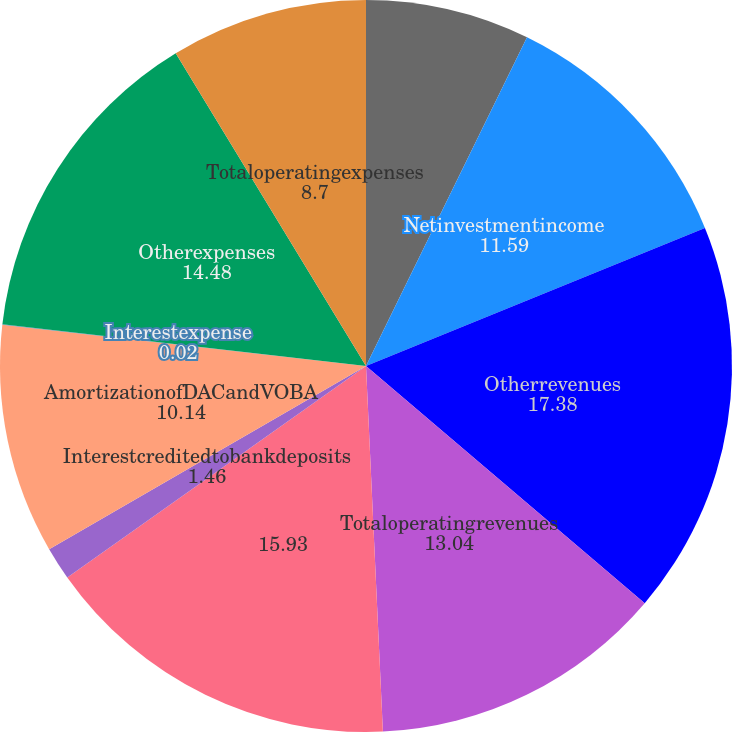Convert chart to OTSL. <chart><loc_0><loc_0><loc_500><loc_500><pie_chart><fcel>Premiums<fcel>Netinvestmentincome<fcel>Otherrevenues<fcel>Totaloperatingrevenues<fcel>Unnamed: 4<fcel>Interestcreditedtobankdeposits<fcel>AmortizationofDACandVOBA<fcel>Interestexpense<fcel>Otherexpenses<fcel>Totaloperatingexpenses<nl><fcel>7.25%<fcel>11.59%<fcel>17.38%<fcel>13.04%<fcel>15.93%<fcel>1.46%<fcel>10.14%<fcel>0.02%<fcel>14.48%<fcel>8.7%<nl></chart> 